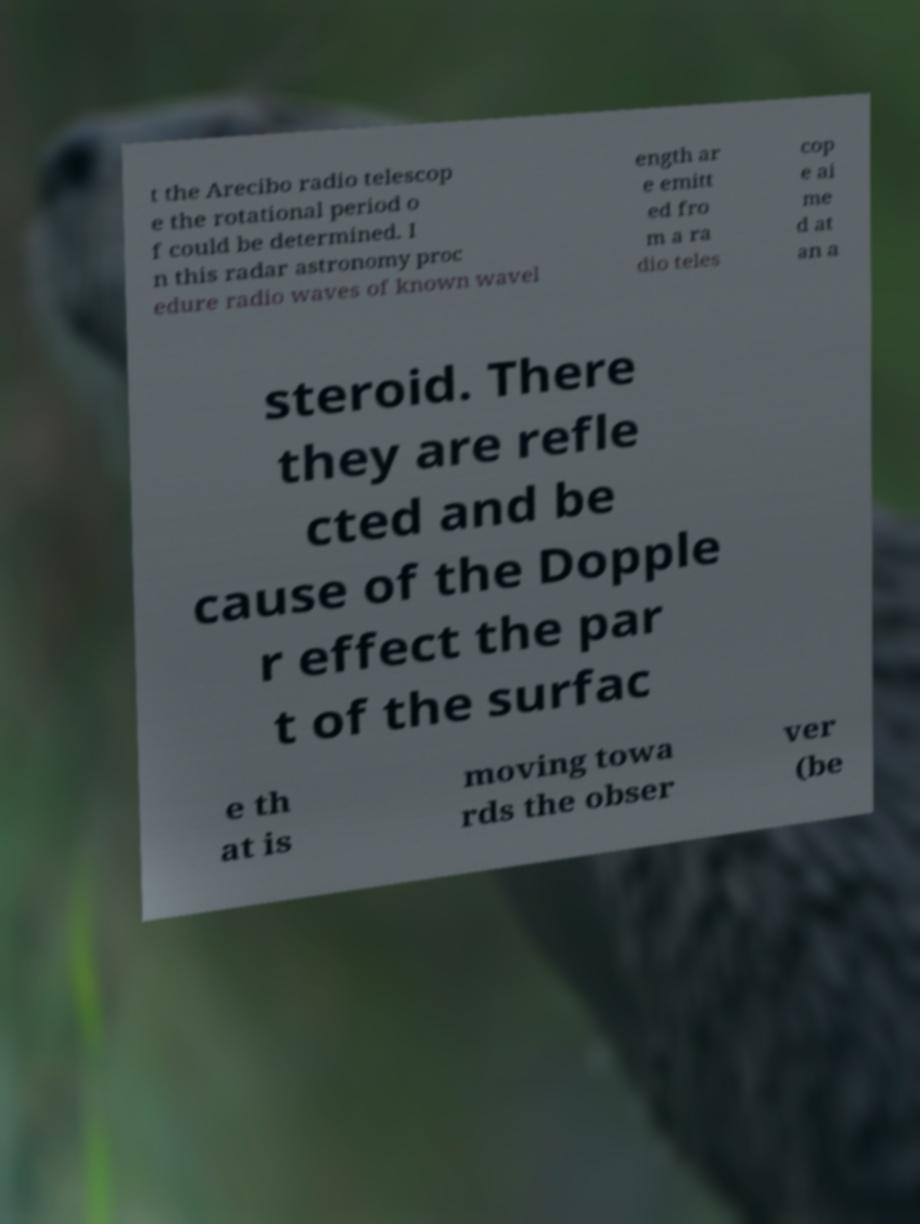Can you read and provide the text displayed in the image?This photo seems to have some interesting text. Can you extract and type it out for me? t the Arecibo radio telescop e the rotational period o f could be determined. I n this radar astronomy proc edure radio waves of known wavel ength ar e emitt ed fro m a ra dio teles cop e ai me d at an a steroid. There they are refle cted and be cause of the Dopple r effect the par t of the surfac e th at is moving towa rds the obser ver (be 